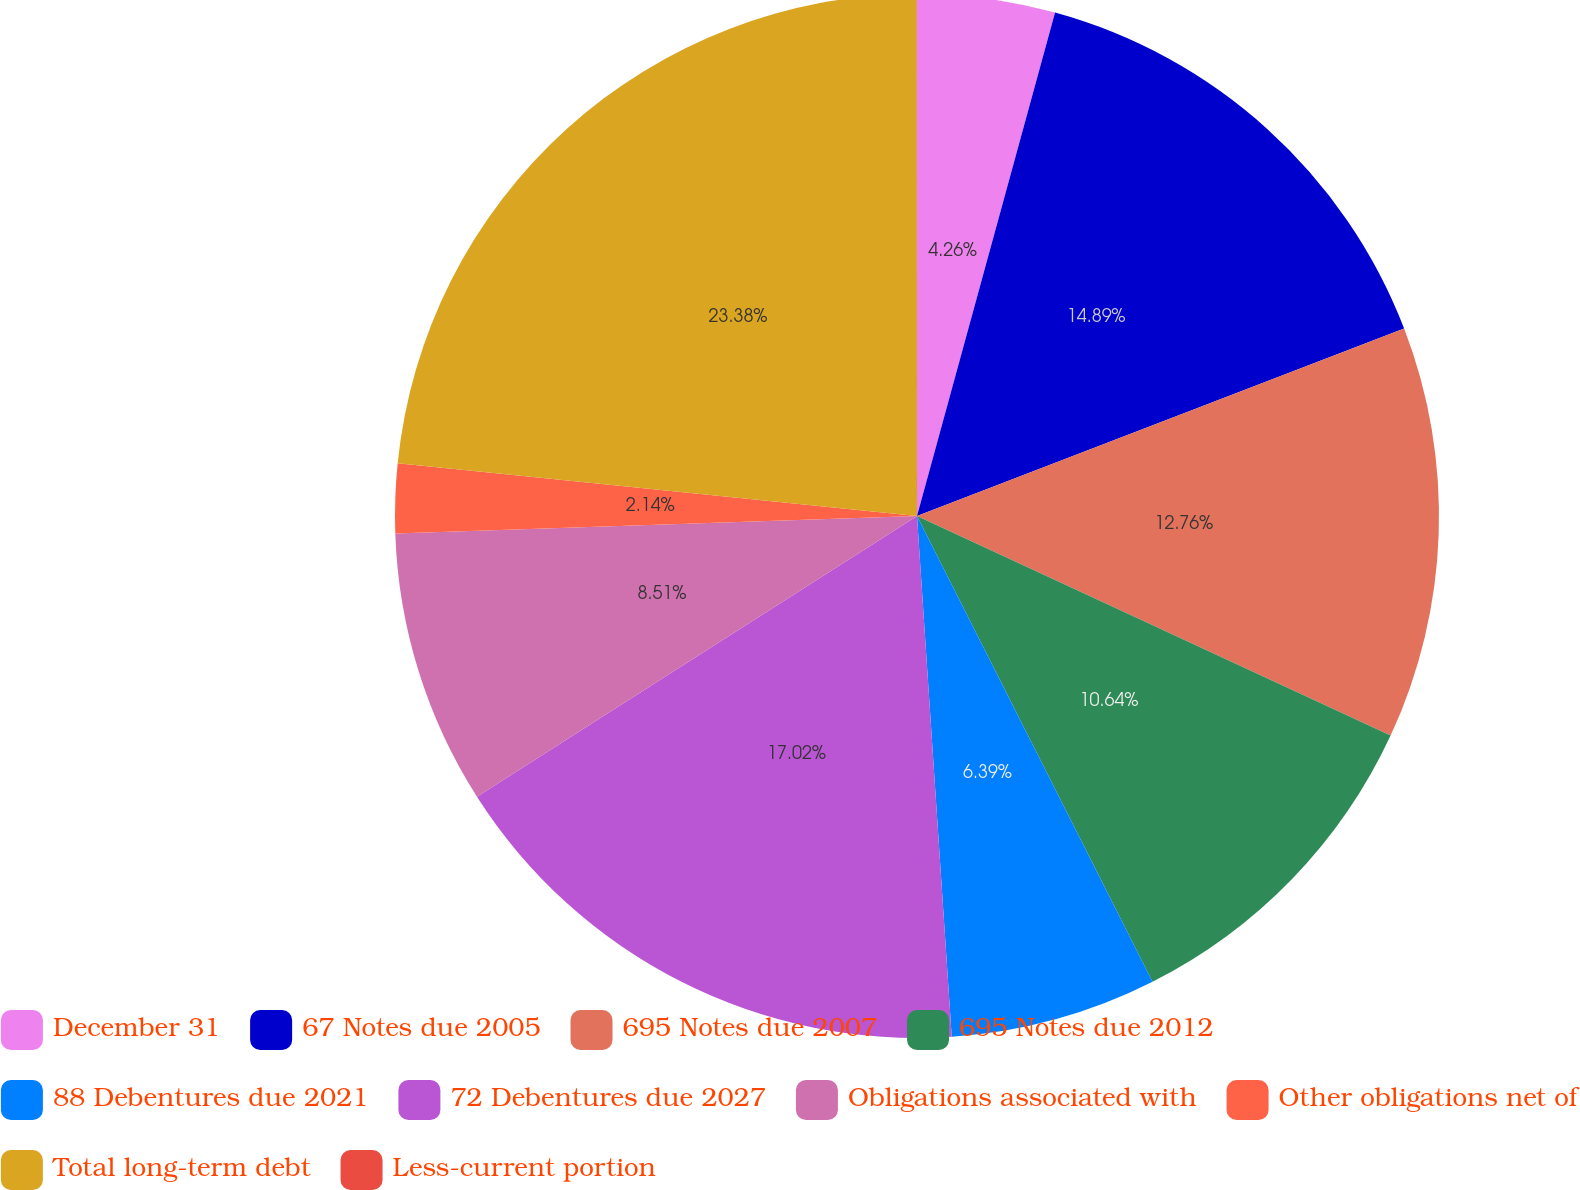<chart> <loc_0><loc_0><loc_500><loc_500><pie_chart><fcel>December 31<fcel>67 Notes due 2005<fcel>695 Notes due 2007<fcel>695 Notes due 2012<fcel>88 Debentures due 2021<fcel>72 Debentures due 2027<fcel>Obligations associated with<fcel>Other obligations net of<fcel>Total long-term debt<fcel>Less-current portion<nl><fcel>4.26%<fcel>14.89%<fcel>12.76%<fcel>10.64%<fcel>6.39%<fcel>17.02%<fcel>8.51%<fcel>2.14%<fcel>23.38%<fcel>0.01%<nl></chart> 